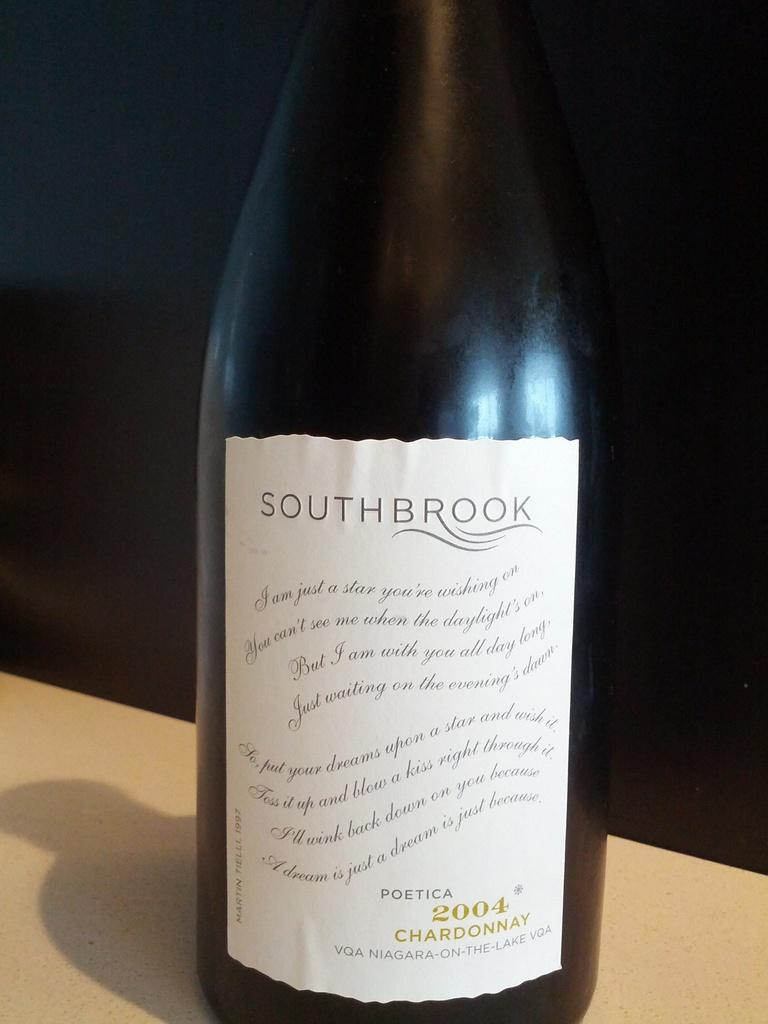<image>
Relay a brief, clear account of the picture shown. a bottle of southbrook wine has a white label 